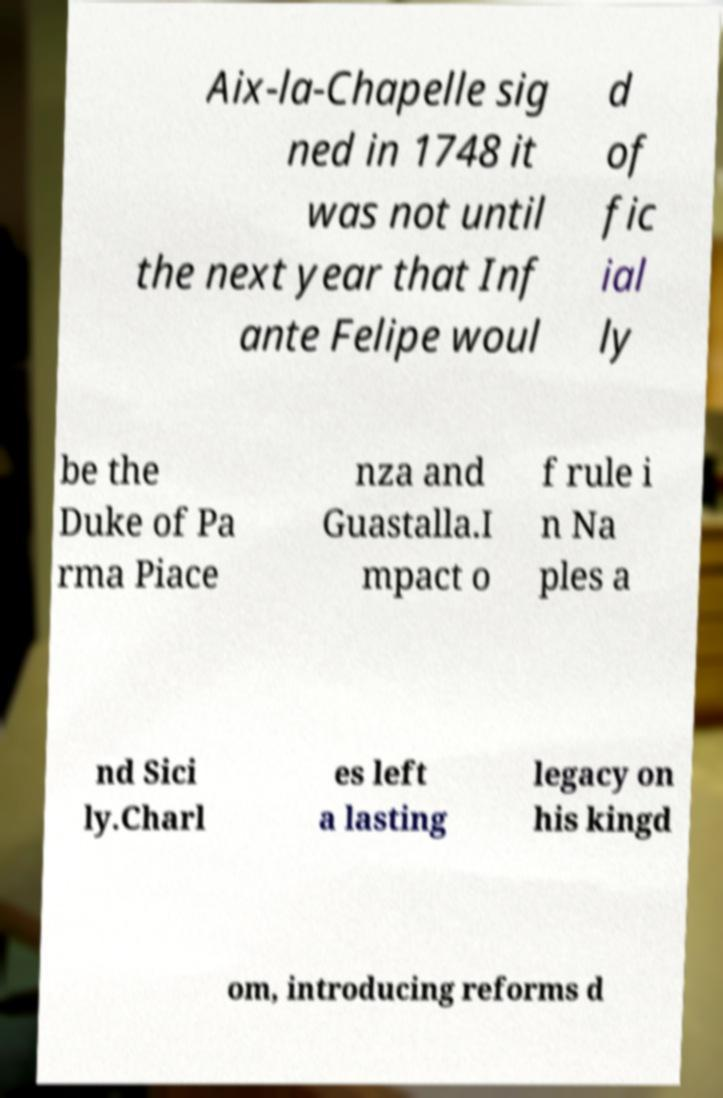Please identify and transcribe the text found in this image. Aix-la-Chapelle sig ned in 1748 it was not until the next year that Inf ante Felipe woul d of fic ial ly be the Duke of Pa rma Piace nza and Guastalla.I mpact o f rule i n Na ples a nd Sici ly.Charl es left a lasting legacy on his kingd om, introducing reforms d 